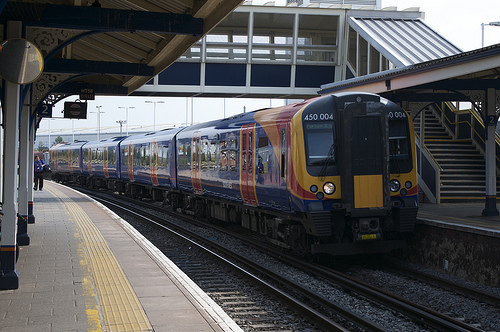Please provide a short description for this region: [0.47, 0.41, 0.51, 0.58]. The described region [0.47, 0.41, 0.51, 0.58] shows the red color train door. This portion of the train provides an entry or exit for passengers, essential for the functionality of the train service. 